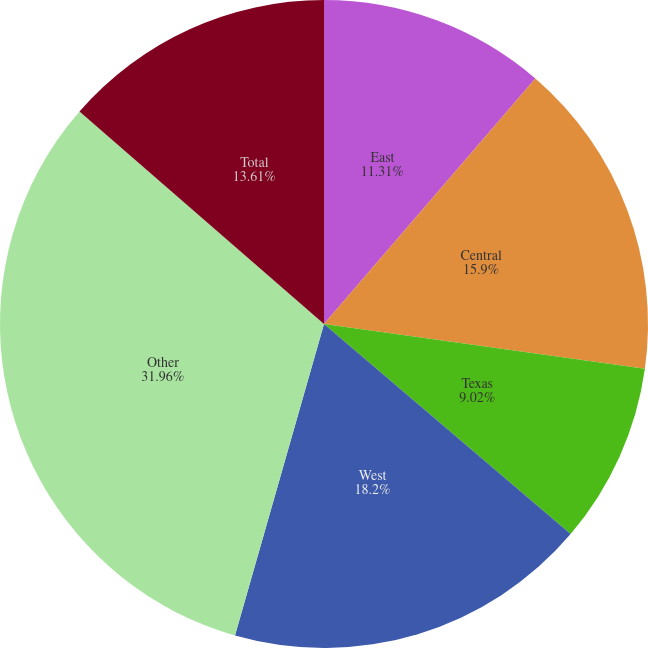Convert chart. <chart><loc_0><loc_0><loc_500><loc_500><pie_chart><fcel>East<fcel>Central<fcel>Texas<fcel>West<fcel>Other<fcel>Total<nl><fcel>11.31%<fcel>15.9%<fcel>9.02%<fcel>18.2%<fcel>31.96%<fcel>13.61%<nl></chart> 